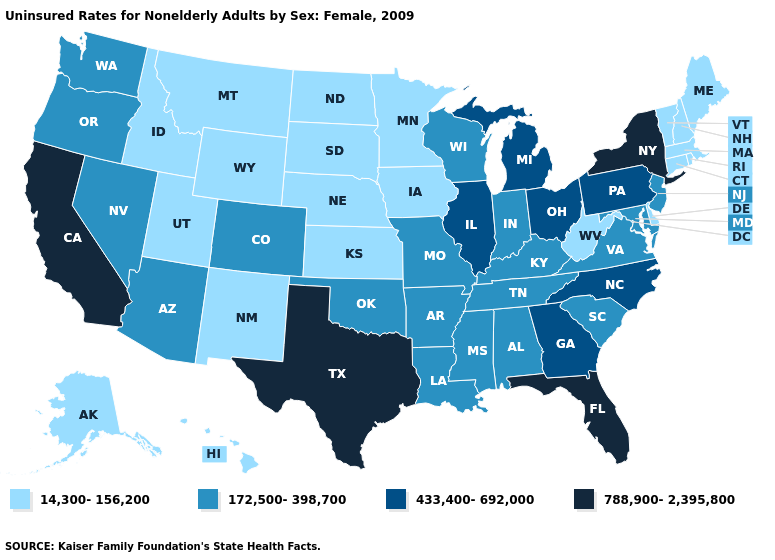What is the highest value in the South ?
Quick response, please. 788,900-2,395,800. What is the highest value in the USA?
Answer briefly. 788,900-2,395,800. Does Georgia have a higher value than Pennsylvania?
Concise answer only. No. What is the value of Oklahoma?
Give a very brief answer. 172,500-398,700. Which states hav the highest value in the South?
Give a very brief answer. Florida, Texas. What is the value of Michigan?
Give a very brief answer. 433,400-692,000. Name the states that have a value in the range 433,400-692,000?
Write a very short answer. Georgia, Illinois, Michigan, North Carolina, Ohio, Pennsylvania. What is the value of Arkansas?
Be succinct. 172,500-398,700. Name the states that have a value in the range 172,500-398,700?
Write a very short answer. Alabama, Arizona, Arkansas, Colorado, Indiana, Kentucky, Louisiana, Maryland, Mississippi, Missouri, Nevada, New Jersey, Oklahoma, Oregon, South Carolina, Tennessee, Virginia, Washington, Wisconsin. Does Maine have the highest value in the USA?
Short answer required. No. Which states hav the highest value in the West?
Be succinct. California. Name the states that have a value in the range 788,900-2,395,800?
Keep it brief. California, Florida, New York, Texas. Name the states that have a value in the range 14,300-156,200?
Keep it brief. Alaska, Connecticut, Delaware, Hawaii, Idaho, Iowa, Kansas, Maine, Massachusetts, Minnesota, Montana, Nebraska, New Hampshire, New Mexico, North Dakota, Rhode Island, South Dakota, Utah, Vermont, West Virginia, Wyoming. What is the value of North Dakota?
Write a very short answer. 14,300-156,200. 